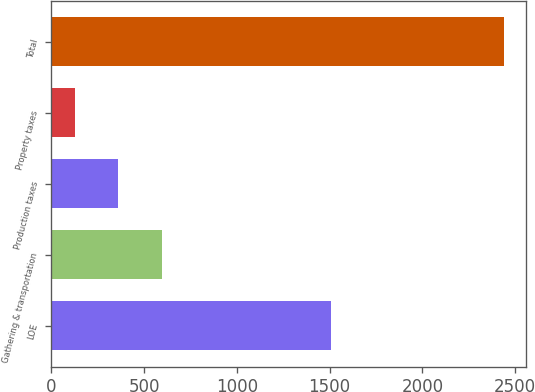<chart> <loc_0><loc_0><loc_500><loc_500><bar_chart><fcel>LOE<fcel>Gathering & transportation<fcel>Production taxes<fcel>Property taxes<fcel>Total<nl><fcel>1509<fcel>595<fcel>359.1<fcel>128<fcel>2439<nl></chart> 